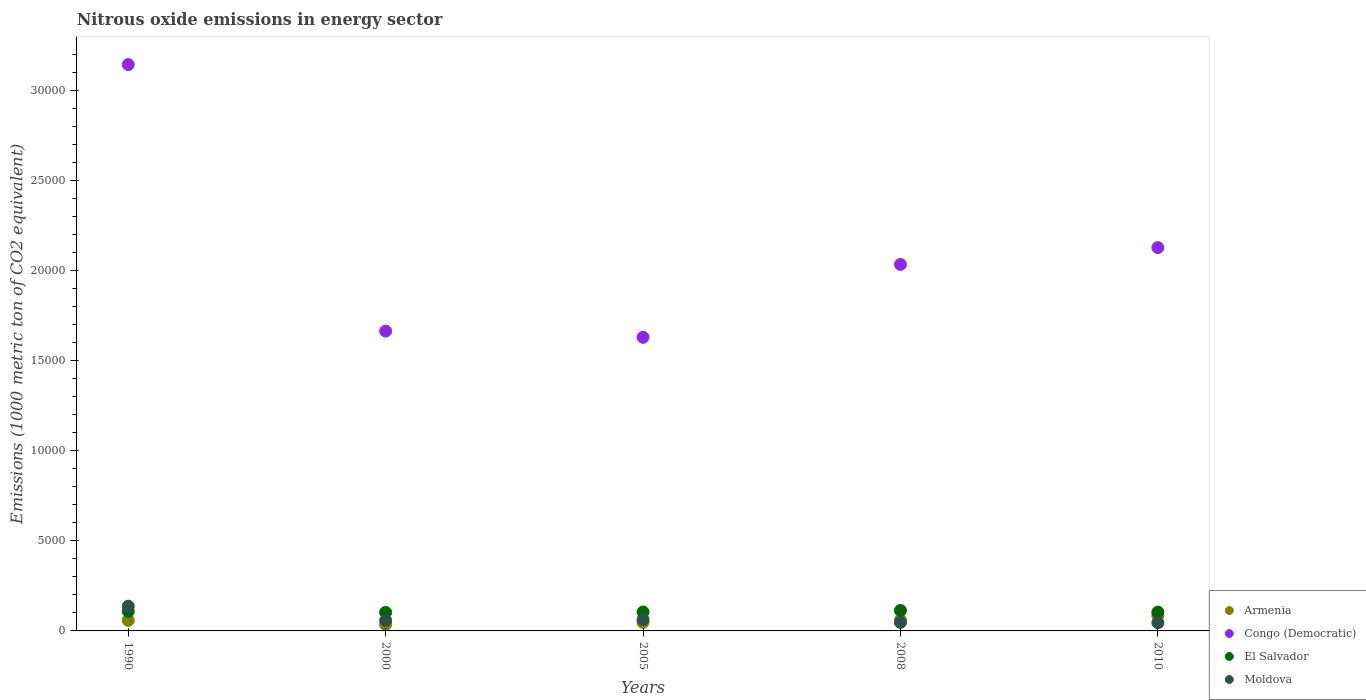Is the number of dotlines equal to the number of legend labels?
Keep it short and to the point. Yes. What is the amount of nitrous oxide emitted in Moldova in 1990?
Offer a terse response. 1373.3. Across all years, what is the maximum amount of nitrous oxide emitted in Congo (Democratic)?
Your answer should be very brief. 3.14e+04. Across all years, what is the minimum amount of nitrous oxide emitted in Armenia?
Offer a terse response. 356.1. In which year was the amount of nitrous oxide emitted in Congo (Democratic) maximum?
Provide a short and direct response. 1990. What is the total amount of nitrous oxide emitted in Moldova in the graph?
Give a very brief answer. 3502.6. What is the difference between the amount of nitrous oxide emitted in Moldova in 2000 and that in 2010?
Ensure brevity in your answer.  127. What is the difference between the amount of nitrous oxide emitted in Armenia in 2005 and the amount of nitrous oxide emitted in Moldova in 1990?
Offer a very short reply. -900. What is the average amount of nitrous oxide emitted in Armenia per year?
Your response must be concise. 572.5. In the year 2005, what is the difference between the amount of nitrous oxide emitted in Congo (Democratic) and amount of nitrous oxide emitted in Armenia?
Keep it short and to the point. 1.58e+04. In how many years, is the amount of nitrous oxide emitted in Armenia greater than 13000 1000 metric ton?
Give a very brief answer. 0. What is the ratio of the amount of nitrous oxide emitted in Moldova in 2000 to that in 2005?
Give a very brief answer. 0.93. Is the amount of nitrous oxide emitted in El Salvador in 2000 less than that in 2010?
Your answer should be compact. Yes. What is the difference between the highest and the second highest amount of nitrous oxide emitted in Moldova?
Keep it short and to the point. 749.2. What is the difference between the highest and the lowest amount of nitrous oxide emitted in El Salvador?
Ensure brevity in your answer.  107. In how many years, is the amount of nitrous oxide emitted in Moldova greater than the average amount of nitrous oxide emitted in Moldova taken over all years?
Provide a succinct answer. 1. Is it the case that in every year, the sum of the amount of nitrous oxide emitted in Moldova and amount of nitrous oxide emitted in Armenia  is greater than the sum of amount of nitrous oxide emitted in Congo (Democratic) and amount of nitrous oxide emitted in El Salvador?
Your response must be concise. No. Is it the case that in every year, the sum of the amount of nitrous oxide emitted in Moldova and amount of nitrous oxide emitted in Congo (Democratic)  is greater than the amount of nitrous oxide emitted in Armenia?
Your response must be concise. Yes. Is the amount of nitrous oxide emitted in Congo (Democratic) strictly greater than the amount of nitrous oxide emitted in El Salvador over the years?
Keep it short and to the point. Yes. How many dotlines are there?
Make the answer very short. 4. What is the difference between two consecutive major ticks on the Y-axis?
Give a very brief answer. 5000. Are the values on the major ticks of Y-axis written in scientific E-notation?
Your answer should be compact. No. Does the graph contain any zero values?
Make the answer very short. No. How many legend labels are there?
Keep it short and to the point. 4. How are the legend labels stacked?
Offer a very short reply. Vertical. What is the title of the graph?
Your response must be concise. Nitrous oxide emissions in energy sector. What is the label or title of the X-axis?
Offer a terse response. Years. What is the label or title of the Y-axis?
Ensure brevity in your answer.  Emissions (1000 metric ton of CO2 equivalent). What is the Emissions (1000 metric ton of CO2 equivalent) of Armenia in 1990?
Provide a short and direct response. 586.2. What is the Emissions (1000 metric ton of CO2 equivalent) in Congo (Democratic) in 1990?
Make the answer very short. 3.14e+04. What is the Emissions (1000 metric ton of CO2 equivalent) of El Salvador in 1990?
Offer a terse response. 1088.8. What is the Emissions (1000 metric ton of CO2 equivalent) of Moldova in 1990?
Your answer should be compact. 1373.3. What is the Emissions (1000 metric ton of CO2 equivalent) of Armenia in 2000?
Your response must be concise. 356.1. What is the Emissions (1000 metric ton of CO2 equivalent) of Congo (Democratic) in 2000?
Give a very brief answer. 1.66e+04. What is the Emissions (1000 metric ton of CO2 equivalent) of El Salvador in 2000?
Your response must be concise. 1028. What is the Emissions (1000 metric ton of CO2 equivalent) of Moldova in 2000?
Offer a very short reply. 579.9. What is the Emissions (1000 metric ton of CO2 equivalent) of Armenia in 2005?
Keep it short and to the point. 473.3. What is the Emissions (1000 metric ton of CO2 equivalent) in Congo (Democratic) in 2005?
Provide a short and direct response. 1.63e+04. What is the Emissions (1000 metric ton of CO2 equivalent) in El Salvador in 2005?
Offer a terse response. 1049.1. What is the Emissions (1000 metric ton of CO2 equivalent) in Moldova in 2005?
Provide a short and direct response. 624.1. What is the Emissions (1000 metric ton of CO2 equivalent) in Armenia in 2008?
Ensure brevity in your answer.  593.5. What is the Emissions (1000 metric ton of CO2 equivalent) of Congo (Democratic) in 2008?
Make the answer very short. 2.03e+04. What is the Emissions (1000 metric ton of CO2 equivalent) of El Salvador in 2008?
Provide a succinct answer. 1135. What is the Emissions (1000 metric ton of CO2 equivalent) of Moldova in 2008?
Your answer should be very brief. 472.4. What is the Emissions (1000 metric ton of CO2 equivalent) of Armenia in 2010?
Make the answer very short. 853.4. What is the Emissions (1000 metric ton of CO2 equivalent) in Congo (Democratic) in 2010?
Make the answer very short. 2.13e+04. What is the Emissions (1000 metric ton of CO2 equivalent) of El Salvador in 2010?
Make the answer very short. 1044.8. What is the Emissions (1000 metric ton of CO2 equivalent) in Moldova in 2010?
Your answer should be very brief. 452.9. Across all years, what is the maximum Emissions (1000 metric ton of CO2 equivalent) of Armenia?
Give a very brief answer. 853.4. Across all years, what is the maximum Emissions (1000 metric ton of CO2 equivalent) in Congo (Democratic)?
Provide a short and direct response. 3.14e+04. Across all years, what is the maximum Emissions (1000 metric ton of CO2 equivalent) in El Salvador?
Make the answer very short. 1135. Across all years, what is the maximum Emissions (1000 metric ton of CO2 equivalent) in Moldova?
Your response must be concise. 1373.3. Across all years, what is the minimum Emissions (1000 metric ton of CO2 equivalent) in Armenia?
Provide a short and direct response. 356.1. Across all years, what is the minimum Emissions (1000 metric ton of CO2 equivalent) of Congo (Democratic)?
Offer a very short reply. 1.63e+04. Across all years, what is the minimum Emissions (1000 metric ton of CO2 equivalent) of El Salvador?
Your response must be concise. 1028. Across all years, what is the minimum Emissions (1000 metric ton of CO2 equivalent) in Moldova?
Provide a succinct answer. 452.9. What is the total Emissions (1000 metric ton of CO2 equivalent) in Armenia in the graph?
Your answer should be very brief. 2862.5. What is the total Emissions (1000 metric ton of CO2 equivalent) in Congo (Democratic) in the graph?
Provide a succinct answer. 1.06e+05. What is the total Emissions (1000 metric ton of CO2 equivalent) in El Salvador in the graph?
Offer a terse response. 5345.7. What is the total Emissions (1000 metric ton of CO2 equivalent) in Moldova in the graph?
Provide a short and direct response. 3502.6. What is the difference between the Emissions (1000 metric ton of CO2 equivalent) of Armenia in 1990 and that in 2000?
Offer a terse response. 230.1. What is the difference between the Emissions (1000 metric ton of CO2 equivalent) in Congo (Democratic) in 1990 and that in 2000?
Your answer should be compact. 1.48e+04. What is the difference between the Emissions (1000 metric ton of CO2 equivalent) in El Salvador in 1990 and that in 2000?
Your response must be concise. 60.8. What is the difference between the Emissions (1000 metric ton of CO2 equivalent) in Moldova in 1990 and that in 2000?
Your response must be concise. 793.4. What is the difference between the Emissions (1000 metric ton of CO2 equivalent) in Armenia in 1990 and that in 2005?
Provide a succinct answer. 112.9. What is the difference between the Emissions (1000 metric ton of CO2 equivalent) of Congo (Democratic) in 1990 and that in 2005?
Ensure brevity in your answer.  1.51e+04. What is the difference between the Emissions (1000 metric ton of CO2 equivalent) of El Salvador in 1990 and that in 2005?
Your response must be concise. 39.7. What is the difference between the Emissions (1000 metric ton of CO2 equivalent) in Moldova in 1990 and that in 2005?
Provide a succinct answer. 749.2. What is the difference between the Emissions (1000 metric ton of CO2 equivalent) of Armenia in 1990 and that in 2008?
Your answer should be very brief. -7.3. What is the difference between the Emissions (1000 metric ton of CO2 equivalent) in Congo (Democratic) in 1990 and that in 2008?
Your response must be concise. 1.11e+04. What is the difference between the Emissions (1000 metric ton of CO2 equivalent) of El Salvador in 1990 and that in 2008?
Offer a very short reply. -46.2. What is the difference between the Emissions (1000 metric ton of CO2 equivalent) in Moldova in 1990 and that in 2008?
Your response must be concise. 900.9. What is the difference between the Emissions (1000 metric ton of CO2 equivalent) in Armenia in 1990 and that in 2010?
Your response must be concise. -267.2. What is the difference between the Emissions (1000 metric ton of CO2 equivalent) in Congo (Democratic) in 1990 and that in 2010?
Give a very brief answer. 1.02e+04. What is the difference between the Emissions (1000 metric ton of CO2 equivalent) in Moldova in 1990 and that in 2010?
Make the answer very short. 920.4. What is the difference between the Emissions (1000 metric ton of CO2 equivalent) of Armenia in 2000 and that in 2005?
Your answer should be very brief. -117.2. What is the difference between the Emissions (1000 metric ton of CO2 equivalent) in Congo (Democratic) in 2000 and that in 2005?
Offer a very short reply. 342.2. What is the difference between the Emissions (1000 metric ton of CO2 equivalent) of El Salvador in 2000 and that in 2005?
Ensure brevity in your answer.  -21.1. What is the difference between the Emissions (1000 metric ton of CO2 equivalent) in Moldova in 2000 and that in 2005?
Your answer should be compact. -44.2. What is the difference between the Emissions (1000 metric ton of CO2 equivalent) in Armenia in 2000 and that in 2008?
Give a very brief answer. -237.4. What is the difference between the Emissions (1000 metric ton of CO2 equivalent) in Congo (Democratic) in 2000 and that in 2008?
Provide a succinct answer. -3700.5. What is the difference between the Emissions (1000 metric ton of CO2 equivalent) in El Salvador in 2000 and that in 2008?
Make the answer very short. -107. What is the difference between the Emissions (1000 metric ton of CO2 equivalent) in Moldova in 2000 and that in 2008?
Provide a succinct answer. 107.5. What is the difference between the Emissions (1000 metric ton of CO2 equivalent) of Armenia in 2000 and that in 2010?
Make the answer very short. -497.3. What is the difference between the Emissions (1000 metric ton of CO2 equivalent) in Congo (Democratic) in 2000 and that in 2010?
Your response must be concise. -4634.4. What is the difference between the Emissions (1000 metric ton of CO2 equivalent) in El Salvador in 2000 and that in 2010?
Ensure brevity in your answer.  -16.8. What is the difference between the Emissions (1000 metric ton of CO2 equivalent) of Moldova in 2000 and that in 2010?
Provide a succinct answer. 127. What is the difference between the Emissions (1000 metric ton of CO2 equivalent) in Armenia in 2005 and that in 2008?
Make the answer very short. -120.2. What is the difference between the Emissions (1000 metric ton of CO2 equivalent) of Congo (Democratic) in 2005 and that in 2008?
Your answer should be compact. -4042.7. What is the difference between the Emissions (1000 metric ton of CO2 equivalent) of El Salvador in 2005 and that in 2008?
Keep it short and to the point. -85.9. What is the difference between the Emissions (1000 metric ton of CO2 equivalent) in Moldova in 2005 and that in 2008?
Offer a very short reply. 151.7. What is the difference between the Emissions (1000 metric ton of CO2 equivalent) of Armenia in 2005 and that in 2010?
Offer a terse response. -380.1. What is the difference between the Emissions (1000 metric ton of CO2 equivalent) of Congo (Democratic) in 2005 and that in 2010?
Give a very brief answer. -4976.6. What is the difference between the Emissions (1000 metric ton of CO2 equivalent) of El Salvador in 2005 and that in 2010?
Give a very brief answer. 4.3. What is the difference between the Emissions (1000 metric ton of CO2 equivalent) in Moldova in 2005 and that in 2010?
Make the answer very short. 171.2. What is the difference between the Emissions (1000 metric ton of CO2 equivalent) of Armenia in 2008 and that in 2010?
Your answer should be very brief. -259.9. What is the difference between the Emissions (1000 metric ton of CO2 equivalent) in Congo (Democratic) in 2008 and that in 2010?
Provide a short and direct response. -933.9. What is the difference between the Emissions (1000 metric ton of CO2 equivalent) in El Salvador in 2008 and that in 2010?
Provide a succinct answer. 90.2. What is the difference between the Emissions (1000 metric ton of CO2 equivalent) of Armenia in 1990 and the Emissions (1000 metric ton of CO2 equivalent) of Congo (Democratic) in 2000?
Your answer should be very brief. -1.61e+04. What is the difference between the Emissions (1000 metric ton of CO2 equivalent) of Armenia in 1990 and the Emissions (1000 metric ton of CO2 equivalent) of El Salvador in 2000?
Your answer should be very brief. -441.8. What is the difference between the Emissions (1000 metric ton of CO2 equivalent) of Armenia in 1990 and the Emissions (1000 metric ton of CO2 equivalent) of Moldova in 2000?
Provide a short and direct response. 6.3. What is the difference between the Emissions (1000 metric ton of CO2 equivalent) in Congo (Democratic) in 1990 and the Emissions (1000 metric ton of CO2 equivalent) in El Salvador in 2000?
Give a very brief answer. 3.04e+04. What is the difference between the Emissions (1000 metric ton of CO2 equivalent) of Congo (Democratic) in 1990 and the Emissions (1000 metric ton of CO2 equivalent) of Moldova in 2000?
Your response must be concise. 3.08e+04. What is the difference between the Emissions (1000 metric ton of CO2 equivalent) of El Salvador in 1990 and the Emissions (1000 metric ton of CO2 equivalent) of Moldova in 2000?
Give a very brief answer. 508.9. What is the difference between the Emissions (1000 metric ton of CO2 equivalent) in Armenia in 1990 and the Emissions (1000 metric ton of CO2 equivalent) in Congo (Democratic) in 2005?
Provide a short and direct response. -1.57e+04. What is the difference between the Emissions (1000 metric ton of CO2 equivalent) in Armenia in 1990 and the Emissions (1000 metric ton of CO2 equivalent) in El Salvador in 2005?
Keep it short and to the point. -462.9. What is the difference between the Emissions (1000 metric ton of CO2 equivalent) in Armenia in 1990 and the Emissions (1000 metric ton of CO2 equivalent) in Moldova in 2005?
Give a very brief answer. -37.9. What is the difference between the Emissions (1000 metric ton of CO2 equivalent) of Congo (Democratic) in 1990 and the Emissions (1000 metric ton of CO2 equivalent) of El Salvador in 2005?
Your answer should be very brief. 3.04e+04. What is the difference between the Emissions (1000 metric ton of CO2 equivalent) in Congo (Democratic) in 1990 and the Emissions (1000 metric ton of CO2 equivalent) in Moldova in 2005?
Make the answer very short. 3.08e+04. What is the difference between the Emissions (1000 metric ton of CO2 equivalent) in El Salvador in 1990 and the Emissions (1000 metric ton of CO2 equivalent) in Moldova in 2005?
Your answer should be compact. 464.7. What is the difference between the Emissions (1000 metric ton of CO2 equivalent) in Armenia in 1990 and the Emissions (1000 metric ton of CO2 equivalent) in Congo (Democratic) in 2008?
Your answer should be very brief. -1.98e+04. What is the difference between the Emissions (1000 metric ton of CO2 equivalent) in Armenia in 1990 and the Emissions (1000 metric ton of CO2 equivalent) in El Salvador in 2008?
Keep it short and to the point. -548.8. What is the difference between the Emissions (1000 metric ton of CO2 equivalent) in Armenia in 1990 and the Emissions (1000 metric ton of CO2 equivalent) in Moldova in 2008?
Provide a succinct answer. 113.8. What is the difference between the Emissions (1000 metric ton of CO2 equivalent) of Congo (Democratic) in 1990 and the Emissions (1000 metric ton of CO2 equivalent) of El Salvador in 2008?
Make the answer very short. 3.03e+04. What is the difference between the Emissions (1000 metric ton of CO2 equivalent) of Congo (Democratic) in 1990 and the Emissions (1000 metric ton of CO2 equivalent) of Moldova in 2008?
Your response must be concise. 3.10e+04. What is the difference between the Emissions (1000 metric ton of CO2 equivalent) in El Salvador in 1990 and the Emissions (1000 metric ton of CO2 equivalent) in Moldova in 2008?
Ensure brevity in your answer.  616.4. What is the difference between the Emissions (1000 metric ton of CO2 equivalent) in Armenia in 1990 and the Emissions (1000 metric ton of CO2 equivalent) in Congo (Democratic) in 2010?
Ensure brevity in your answer.  -2.07e+04. What is the difference between the Emissions (1000 metric ton of CO2 equivalent) in Armenia in 1990 and the Emissions (1000 metric ton of CO2 equivalent) in El Salvador in 2010?
Ensure brevity in your answer.  -458.6. What is the difference between the Emissions (1000 metric ton of CO2 equivalent) of Armenia in 1990 and the Emissions (1000 metric ton of CO2 equivalent) of Moldova in 2010?
Keep it short and to the point. 133.3. What is the difference between the Emissions (1000 metric ton of CO2 equivalent) in Congo (Democratic) in 1990 and the Emissions (1000 metric ton of CO2 equivalent) in El Salvador in 2010?
Your response must be concise. 3.04e+04. What is the difference between the Emissions (1000 metric ton of CO2 equivalent) in Congo (Democratic) in 1990 and the Emissions (1000 metric ton of CO2 equivalent) in Moldova in 2010?
Your response must be concise. 3.10e+04. What is the difference between the Emissions (1000 metric ton of CO2 equivalent) in El Salvador in 1990 and the Emissions (1000 metric ton of CO2 equivalent) in Moldova in 2010?
Give a very brief answer. 635.9. What is the difference between the Emissions (1000 metric ton of CO2 equivalent) of Armenia in 2000 and the Emissions (1000 metric ton of CO2 equivalent) of Congo (Democratic) in 2005?
Give a very brief answer. -1.59e+04. What is the difference between the Emissions (1000 metric ton of CO2 equivalent) in Armenia in 2000 and the Emissions (1000 metric ton of CO2 equivalent) in El Salvador in 2005?
Your answer should be very brief. -693. What is the difference between the Emissions (1000 metric ton of CO2 equivalent) in Armenia in 2000 and the Emissions (1000 metric ton of CO2 equivalent) in Moldova in 2005?
Your answer should be compact. -268. What is the difference between the Emissions (1000 metric ton of CO2 equivalent) in Congo (Democratic) in 2000 and the Emissions (1000 metric ton of CO2 equivalent) in El Salvador in 2005?
Offer a very short reply. 1.56e+04. What is the difference between the Emissions (1000 metric ton of CO2 equivalent) in Congo (Democratic) in 2000 and the Emissions (1000 metric ton of CO2 equivalent) in Moldova in 2005?
Make the answer very short. 1.60e+04. What is the difference between the Emissions (1000 metric ton of CO2 equivalent) in El Salvador in 2000 and the Emissions (1000 metric ton of CO2 equivalent) in Moldova in 2005?
Give a very brief answer. 403.9. What is the difference between the Emissions (1000 metric ton of CO2 equivalent) of Armenia in 2000 and the Emissions (1000 metric ton of CO2 equivalent) of Congo (Democratic) in 2008?
Make the answer very short. -2.00e+04. What is the difference between the Emissions (1000 metric ton of CO2 equivalent) in Armenia in 2000 and the Emissions (1000 metric ton of CO2 equivalent) in El Salvador in 2008?
Offer a terse response. -778.9. What is the difference between the Emissions (1000 metric ton of CO2 equivalent) in Armenia in 2000 and the Emissions (1000 metric ton of CO2 equivalent) in Moldova in 2008?
Ensure brevity in your answer.  -116.3. What is the difference between the Emissions (1000 metric ton of CO2 equivalent) of Congo (Democratic) in 2000 and the Emissions (1000 metric ton of CO2 equivalent) of El Salvador in 2008?
Give a very brief answer. 1.55e+04. What is the difference between the Emissions (1000 metric ton of CO2 equivalent) of Congo (Democratic) in 2000 and the Emissions (1000 metric ton of CO2 equivalent) of Moldova in 2008?
Provide a succinct answer. 1.62e+04. What is the difference between the Emissions (1000 metric ton of CO2 equivalent) in El Salvador in 2000 and the Emissions (1000 metric ton of CO2 equivalent) in Moldova in 2008?
Ensure brevity in your answer.  555.6. What is the difference between the Emissions (1000 metric ton of CO2 equivalent) of Armenia in 2000 and the Emissions (1000 metric ton of CO2 equivalent) of Congo (Democratic) in 2010?
Provide a short and direct response. -2.09e+04. What is the difference between the Emissions (1000 metric ton of CO2 equivalent) of Armenia in 2000 and the Emissions (1000 metric ton of CO2 equivalent) of El Salvador in 2010?
Provide a succinct answer. -688.7. What is the difference between the Emissions (1000 metric ton of CO2 equivalent) in Armenia in 2000 and the Emissions (1000 metric ton of CO2 equivalent) in Moldova in 2010?
Your response must be concise. -96.8. What is the difference between the Emissions (1000 metric ton of CO2 equivalent) of Congo (Democratic) in 2000 and the Emissions (1000 metric ton of CO2 equivalent) of El Salvador in 2010?
Offer a very short reply. 1.56e+04. What is the difference between the Emissions (1000 metric ton of CO2 equivalent) of Congo (Democratic) in 2000 and the Emissions (1000 metric ton of CO2 equivalent) of Moldova in 2010?
Offer a terse response. 1.62e+04. What is the difference between the Emissions (1000 metric ton of CO2 equivalent) of El Salvador in 2000 and the Emissions (1000 metric ton of CO2 equivalent) of Moldova in 2010?
Your answer should be compact. 575.1. What is the difference between the Emissions (1000 metric ton of CO2 equivalent) in Armenia in 2005 and the Emissions (1000 metric ton of CO2 equivalent) in Congo (Democratic) in 2008?
Make the answer very short. -1.99e+04. What is the difference between the Emissions (1000 metric ton of CO2 equivalent) in Armenia in 2005 and the Emissions (1000 metric ton of CO2 equivalent) in El Salvador in 2008?
Ensure brevity in your answer.  -661.7. What is the difference between the Emissions (1000 metric ton of CO2 equivalent) of Armenia in 2005 and the Emissions (1000 metric ton of CO2 equivalent) of Moldova in 2008?
Offer a terse response. 0.9. What is the difference between the Emissions (1000 metric ton of CO2 equivalent) of Congo (Democratic) in 2005 and the Emissions (1000 metric ton of CO2 equivalent) of El Salvador in 2008?
Provide a succinct answer. 1.52e+04. What is the difference between the Emissions (1000 metric ton of CO2 equivalent) of Congo (Democratic) in 2005 and the Emissions (1000 metric ton of CO2 equivalent) of Moldova in 2008?
Offer a very short reply. 1.58e+04. What is the difference between the Emissions (1000 metric ton of CO2 equivalent) of El Salvador in 2005 and the Emissions (1000 metric ton of CO2 equivalent) of Moldova in 2008?
Your answer should be very brief. 576.7. What is the difference between the Emissions (1000 metric ton of CO2 equivalent) of Armenia in 2005 and the Emissions (1000 metric ton of CO2 equivalent) of Congo (Democratic) in 2010?
Keep it short and to the point. -2.08e+04. What is the difference between the Emissions (1000 metric ton of CO2 equivalent) of Armenia in 2005 and the Emissions (1000 metric ton of CO2 equivalent) of El Salvador in 2010?
Make the answer very short. -571.5. What is the difference between the Emissions (1000 metric ton of CO2 equivalent) in Armenia in 2005 and the Emissions (1000 metric ton of CO2 equivalent) in Moldova in 2010?
Your response must be concise. 20.4. What is the difference between the Emissions (1000 metric ton of CO2 equivalent) in Congo (Democratic) in 2005 and the Emissions (1000 metric ton of CO2 equivalent) in El Salvador in 2010?
Your answer should be very brief. 1.53e+04. What is the difference between the Emissions (1000 metric ton of CO2 equivalent) of Congo (Democratic) in 2005 and the Emissions (1000 metric ton of CO2 equivalent) of Moldova in 2010?
Offer a very short reply. 1.58e+04. What is the difference between the Emissions (1000 metric ton of CO2 equivalent) in El Salvador in 2005 and the Emissions (1000 metric ton of CO2 equivalent) in Moldova in 2010?
Give a very brief answer. 596.2. What is the difference between the Emissions (1000 metric ton of CO2 equivalent) in Armenia in 2008 and the Emissions (1000 metric ton of CO2 equivalent) in Congo (Democratic) in 2010?
Offer a very short reply. -2.07e+04. What is the difference between the Emissions (1000 metric ton of CO2 equivalent) of Armenia in 2008 and the Emissions (1000 metric ton of CO2 equivalent) of El Salvador in 2010?
Offer a terse response. -451.3. What is the difference between the Emissions (1000 metric ton of CO2 equivalent) in Armenia in 2008 and the Emissions (1000 metric ton of CO2 equivalent) in Moldova in 2010?
Keep it short and to the point. 140.6. What is the difference between the Emissions (1000 metric ton of CO2 equivalent) of Congo (Democratic) in 2008 and the Emissions (1000 metric ton of CO2 equivalent) of El Salvador in 2010?
Your response must be concise. 1.93e+04. What is the difference between the Emissions (1000 metric ton of CO2 equivalent) of Congo (Democratic) in 2008 and the Emissions (1000 metric ton of CO2 equivalent) of Moldova in 2010?
Ensure brevity in your answer.  1.99e+04. What is the difference between the Emissions (1000 metric ton of CO2 equivalent) in El Salvador in 2008 and the Emissions (1000 metric ton of CO2 equivalent) in Moldova in 2010?
Your answer should be compact. 682.1. What is the average Emissions (1000 metric ton of CO2 equivalent) of Armenia per year?
Make the answer very short. 572.5. What is the average Emissions (1000 metric ton of CO2 equivalent) in Congo (Democratic) per year?
Your response must be concise. 2.12e+04. What is the average Emissions (1000 metric ton of CO2 equivalent) in El Salvador per year?
Your response must be concise. 1069.14. What is the average Emissions (1000 metric ton of CO2 equivalent) in Moldova per year?
Your answer should be very brief. 700.52. In the year 1990, what is the difference between the Emissions (1000 metric ton of CO2 equivalent) in Armenia and Emissions (1000 metric ton of CO2 equivalent) in Congo (Democratic)?
Provide a succinct answer. -3.08e+04. In the year 1990, what is the difference between the Emissions (1000 metric ton of CO2 equivalent) of Armenia and Emissions (1000 metric ton of CO2 equivalent) of El Salvador?
Give a very brief answer. -502.6. In the year 1990, what is the difference between the Emissions (1000 metric ton of CO2 equivalent) of Armenia and Emissions (1000 metric ton of CO2 equivalent) of Moldova?
Your response must be concise. -787.1. In the year 1990, what is the difference between the Emissions (1000 metric ton of CO2 equivalent) of Congo (Democratic) and Emissions (1000 metric ton of CO2 equivalent) of El Salvador?
Your answer should be very brief. 3.03e+04. In the year 1990, what is the difference between the Emissions (1000 metric ton of CO2 equivalent) in Congo (Democratic) and Emissions (1000 metric ton of CO2 equivalent) in Moldova?
Your response must be concise. 3.01e+04. In the year 1990, what is the difference between the Emissions (1000 metric ton of CO2 equivalent) in El Salvador and Emissions (1000 metric ton of CO2 equivalent) in Moldova?
Make the answer very short. -284.5. In the year 2000, what is the difference between the Emissions (1000 metric ton of CO2 equivalent) in Armenia and Emissions (1000 metric ton of CO2 equivalent) in Congo (Democratic)?
Your answer should be compact. -1.63e+04. In the year 2000, what is the difference between the Emissions (1000 metric ton of CO2 equivalent) in Armenia and Emissions (1000 metric ton of CO2 equivalent) in El Salvador?
Ensure brevity in your answer.  -671.9. In the year 2000, what is the difference between the Emissions (1000 metric ton of CO2 equivalent) in Armenia and Emissions (1000 metric ton of CO2 equivalent) in Moldova?
Make the answer very short. -223.8. In the year 2000, what is the difference between the Emissions (1000 metric ton of CO2 equivalent) in Congo (Democratic) and Emissions (1000 metric ton of CO2 equivalent) in El Salvador?
Ensure brevity in your answer.  1.56e+04. In the year 2000, what is the difference between the Emissions (1000 metric ton of CO2 equivalent) of Congo (Democratic) and Emissions (1000 metric ton of CO2 equivalent) of Moldova?
Provide a short and direct response. 1.61e+04. In the year 2000, what is the difference between the Emissions (1000 metric ton of CO2 equivalent) of El Salvador and Emissions (1000 metric ton of CO2 equivalent) of Moldova?
Your answer should be very brief. 448.1. In the year 2005, what is the difference between the Emissions (1000 metric ton of CO2 equivalent) in Armenia and Emissions (1000 metric ton of CO2 equivalent) in Congo (Democratic)?
Offer a very short reply. -1.58e+04. In the year 2005, what is the difference between the Emissions (1000 metric ton of CO2 equivalent) of Armenia and Emissions (1000 metric ton of CO2 equivalent) of El Salvador?
Your answer should be compact. -575.8. In the year 2005, what is the difference between the Emissions (1000 metric ton of CO2 equivalent) of Armenia and Emissions (1000 metric ton of CO2 equivalent) of Moldova?
Your answer should be very brief. -150.8. In the year 2005, what is the difference between the Emissions (1000 metric ton of CO2 equivalent) in Congo (Democratic) and Emissions (1000 metric ton of CO2 equivalent) in El Salvador?
Your answer should be compact. 1.52e+04. In the year 2005, what is the difference between the Emissions (1000 metric ton of CO2 equivalent) in Congo (Democratic) and Emissions (1000 metric ton of CO2 equivalent) in Moldova?
Ensure brevity in your answer.  1.57e+04. In the year 2005, what is the difference between the Emissions (1000 metric ton of CO2 equivalent) of El Salvador and Emissions (1000 metric ton of CO2 equivalent) of Moldova?
Offer a very short reply. 425. In the year 2008, what is the difference between the Emissions (1000 metric ton of CO2 equivalent) in Armenia and Emissions (1000 metric ton of CO2 equivalent) in Congo (Democratic)?
Give a very brief answer. -1.97e+04. In the year 2008, what is the difference between the Emissions (1000 metric ton of CO2 equivalent) of Armenia and Emissions (1000 metric ton of CO2 equivalent) of El Salvador?
Keep it short and to the point. -541.5. In the year 2008, what is the difference between the Emissions (1000 metric ton of CO2 equivalent) of Armenia and Emissions (1000 metric ton of CO2 equivalent) of Moldova?
Ensure brevity in your answer.  121.1. In the year 2008, what is the difference between the Emissions (1000 metric ton of CO2 equivalent) of Congo (Democratic) and Emissions (1000 metric ton of CO2 equivalent) of El Salvador?
Make the answer very short. 1.92e+04. In the year 2008, what is the difference between the Emissions (1000 metric ton of CO2 equivalent) of Congo (Democratic) and Emissions (1000 metric ton of CO2 equivalent) of Moldova?
Your response must be concise. 1.99e+04. In the year 2008, what is the difference between the Emissions (1000 metric ton of CO2 equivalent) in El Salvador and Emissions (1000 metric ton of CO2 equivalent) in Moldova?
Keep it short and to the point. 662.6. In the year 2010, what is the difference between the Emissions (1000 metric ton of CO2 equivalent) of Armenia and Emissions (1000 metric ton of CO2 equivalent) of Congo (Democratic)?
Offer a terse response. -2.04e+04. In the year 2010, what is the difference between the Emissions (1000 metric ton of CO2 equivalent) in Armenia and Emissions (1000 metric ton of CO2 equivalent) in El Salvador?
Provide a short and direct response. -191.4. In the year 2010, what is the difference between the Emissions (1000 metric ton of CO2 equivalent) in Armenia and Emissions (1000 metric ton of CO2 equivalent) in Moldova?
Give a very brief answer. 400.5. In the year 2010, what is the difference between the Emissions (1000 metric ton of CO2 equivalent) of Congo (Democratic) and Emissions (1000 metric ton of CO2 equivalent) of El Salvador?
Ensure brevity in your answer.  2.02e+04. In the year 2010, what is the difference between the Emissions (1000 metric ton of CO2 equivalent) in Congo (Democratic) and Emissions (1000 metric ton of CO2 equivalent) in Moldova?
Make the answer very short. 2.08e+04. In the year 2010, what is the difference between the Emissions (1000 metric ton of CO2 equivalent) of El Salvador and Emissions (1000 metric ton of CO2 equivalent) of Moldova?
Offer a very short reply. 591.9. What is the ratio of the Emissions (1000 metric ton of CO2 equivalent) in Armenia in 1990 to that in 2000?
Give a very brief answer. 1.65. What is the ratio of the Emissions (1000 metric ton of CO2 equivalent) in Congo (Democratic) in 1990 to that in 2000?
Provide a succinct answer. 1.89. What is the ratio of the Emissions (1000 metric ton of CO2 equivalent) of El Salvador in 1990 to that in 2000?
Your response must be concise. 1.06. What is the ratio of the Emissions (1000 metric ton of CO2 equivalent) of Moldova in 1990 to that in 2000?
Offer a very short reply. 2.37. What is the ratio of the Emissions (1000 metric ton of CO2 equivalent) of Armenia in 1990 to that in 2005?
Your answer should be compact. 1.24. What is the ratio of the Emissions (1000 metric ton of CO2 equivalent) in Congo (Democratic) in 1990 to that in 2005?
Make the answer very short. 1.93. What is the ratio of the Emissions (1000 metric ton of CO2 equivalent) of El Salvador in 1990 to that in 2005?
Offer a very short reply. 1.04. What is the ratio of the Emissions (1000 metric ton of CO2 equivalent) in Moldova in 1990 to that in 2005?
Give a very brief answer. 2.2. What is the ratio of the Emissions (1000 metric ton of CO2 equivalent) of Armenia in 1990 to that in 2008?
Provide a succinct answer. 0.99. What is the ratio of the Emissions (1000 metric ton of CO2 equivalent) in Congo (Democratic) in 1990 to that in 2008?
Give a very brief answer. 1.55. What is the ratio of the Emissions (1000 metric ton of CO2 equivalent) of El Salvador in 1990 to that in 2008?
Your answer should be very brief. 0.96. What is the ratio of the Emissions (1000 metric ton of CO2 equivalent) of Moldova in 1990 to that in 2008?
Your response must be concise. 2.91. What is the ratio of the Emissions (1000 metric ton of CO2 equivalent) in Armenia in 1990 to that in 2010?
Provide a succinct answer. 0.69. What is the ratio of the Emissions (1000 metric ton of CO2 equivalent) of Congo (Democratic) in 1990 to that in 2010?
Make the answer very short. 1.48. What is the ratio of the Emissions (1000 metric ton of CO2 equivalent) of El Salvador in 1990 to that in 2010?
Your response must be concise. 1.04. What is the ratio of the Emissions (1000 metric ton of CO2 equivalent) in Moldova in 1990 to that in 2010?
Your response must be concise. 3.03. What is the ratio of the Emissions (1000 metric ton of CO2 equivalent) of Armenia in 2000 to that in 2005?
Provide a short and direct response. 0.75. What is the ratio of the Emissions (1000 metric ton of CO2 equivalent) in Congo (Democratic) in 2000 to that in 2005?
Keep it short and to the point. 1.02. What is the ratio of the Emissions (1000 metric ton of CO2 equivalent) of El Salvador in 2000 to that in 2005?
Your response must be concise. 0.98. What is the ratio of the Emissions (1000 metric ton of CO2 equivalent) of Moldova in 2000 to that in 2005?
Offer a terse response. 0.93. What is the ratio of the Emissions (1000 metric ton of CO2 equivalent) in Congo (Democratic) in 2000 to that in 2008?
Offer a very short reply. 0.82. What is the ratio of the Emissions (1000 metric ton of CO2 equivalent) of El Salvador in 2000 to that in 2008?
Provide a short and direct response. 0.91. What is the ratio of the Emissions (1000 metric ton of CO2 equivalent) of Moldova in 2000 to that in 2008?
Provide a succinct answer. 1.23. What is the ratio of the Emissions (1000 metric ton of CO2 equivalent) of Armenia in 2000 to that in 2010?
Ensure brevity in your answer.  0.42. What is the ratio of the Emissions (1000 metric ton of CO2 equivalent) of Congo (Democratic) in 2000 to that in 2010?
Offer a terse response. 0.78. What is the ratio of the Emissions (1000 metric ton of CO2 equivalent) in El Salvador in 2000 to that in 2010?
Provide a short and direct response. 0.98. What is the ratio of the Emissions (1000 metric ton of CO2 equivalent) in Moldova in 2000 to that in 2010?
Ensure brevity in your answer.  1.28. What is the ratio of the Emissions (1000 metric ton of CO2 equivalent) in Armenia in 2005 to that in 2008?
Make the answer very short. 0.8. What is the ratio of the Emissions (1000 metric ton of CO2 equivalent) of Congo (Democratic) in 2005 to that in 2008?
Your answer should be compact. 0.8. What is the ratio of the Emissions (1000 metric ton of CO2 equivalent) of El Salvador in 2005 to that in 2008?
Give a very brief answer. 0.92. What is the ratio of the Emissions (1000 metric ton of CO2 equivalent) of Moldova in 2005 to that in 2008?
Offer a very short reply. 1.32. What is the ratio of the Emissions (1000 metric ton of CO2 equivalent) of Armenia in 2005 to that in 2010?
Offer a very short reply. 0.55. What is the ratio of the Emissions (1000 metric ton of CO2 equivalent) in Congo (Democratic) in 2005 to that in 2010?
Offer a very short reply. 0.77. What is the ratio of the Emissions (1000 metric ton of CO2 equivalent) of El Salvador in 2005 to that in 2010?
Provide a succinct answer. 1. What is the ratio of the Emissions (1000 metric ton of CO2 equivalent) of Moldova in 2005 to that in 2010?
Make the answer very short. 1.38. What is the ratio of the Emissions (1000 metric ton of CO2 equivalent) of Armenia in 2008 to that in 2010?
Ensure brevity in your answer.  0.7. What is the ratio of the Emissions (1000 metric ton of CO2 equivalent) in Congo (Democratic) in 2008 to that in 2010?
Ensure brevity in your answer.  0.96. What is the ratio of the Emissions (1000 metric ton of CO2 equivalent) of El Salvador in 2008 to that in 2010?
Provide a short and direct response. 1.09. What is the ratio of the Emissions (1000 metric ton of CO2 equivalent) in Moldova in 2008 to that in 2010?
Offer a terse response. 1.04. What is the difference between the highest and the second highest Emissions (1000 metric ton of CO2 equivalent) in Armenia?
Provide a short and direct response. 259.9. What is the difference between the highest and the second highest Emissions (1000 metric ton of CO2 equivalent) of Congo (Democratic)?
Offer a terse response. 1.02e+04. What is the difference between the highest and the second highest Emissions (1000 metric ton of CO2 equivalent) of El Salvador?
Provide a succinct answer. 46.2. What is the difference between the highest and the second highest Emissions (1000 metric ton of CO2 equivalent) of Moldova?
Make the answer very short. 749.2. What is the difference between the highest and the lowest Emissions (1000 metric ton of CO2 equivalent) in Armenia?
Your response must be concise. 497.3. What is the difference between the highest and the lowest Emissions (1000 metric ton of CO2 equivalent) of Congo (Democratic)?
Make the answer very short. 1.51e+04. What is the difference between the highest and the lowest Emissions (1000 metric ton of CO2 equivalent) in El Salvador?
Offer a very short reply. 107. What is the difference between the highest and the lowest Emissions (1000 metric ton of CO2 equivalent) of Moldova?
Your response must be concise. 920.4. 